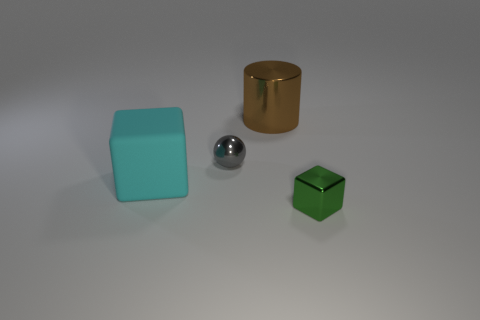Add 2 large gray rubber cylinders. How many objects exist? 6 Subtract all spheres. How many objects are left? 3 Subtract 1 green cubes. How many objects are left? 3 Subtract all large green rubber blocks. Subtract all shiny balls. How many objects are left? 3 Add 1 big cyan objects. How many big cyan objects are left? 2 Add 3 small brown spheres. How many small brown spheres exist? 3 